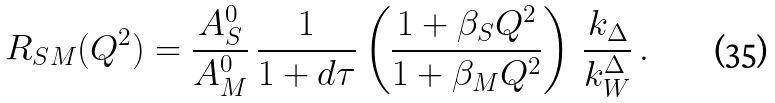Convert formula to latex. <formula><loc_0><loc_0><loc_500><loc_500>R _ { S M } ( Q ^ { 2 } ) = \frac { A _ { S } ^ { 0 } } { A _ { M } ^ { 0 } } \, \frac { 1 } { 1 + d \tau } \left ( \frac { 1 + \beta _ { S } Q ^ { 2 } } { 1 + \beta _ { M } Q ^ { 2 } } \right ) \, \frac { k _ { \Delta } } { k _ { W } ^ { \Delta } } \, .</formula> 